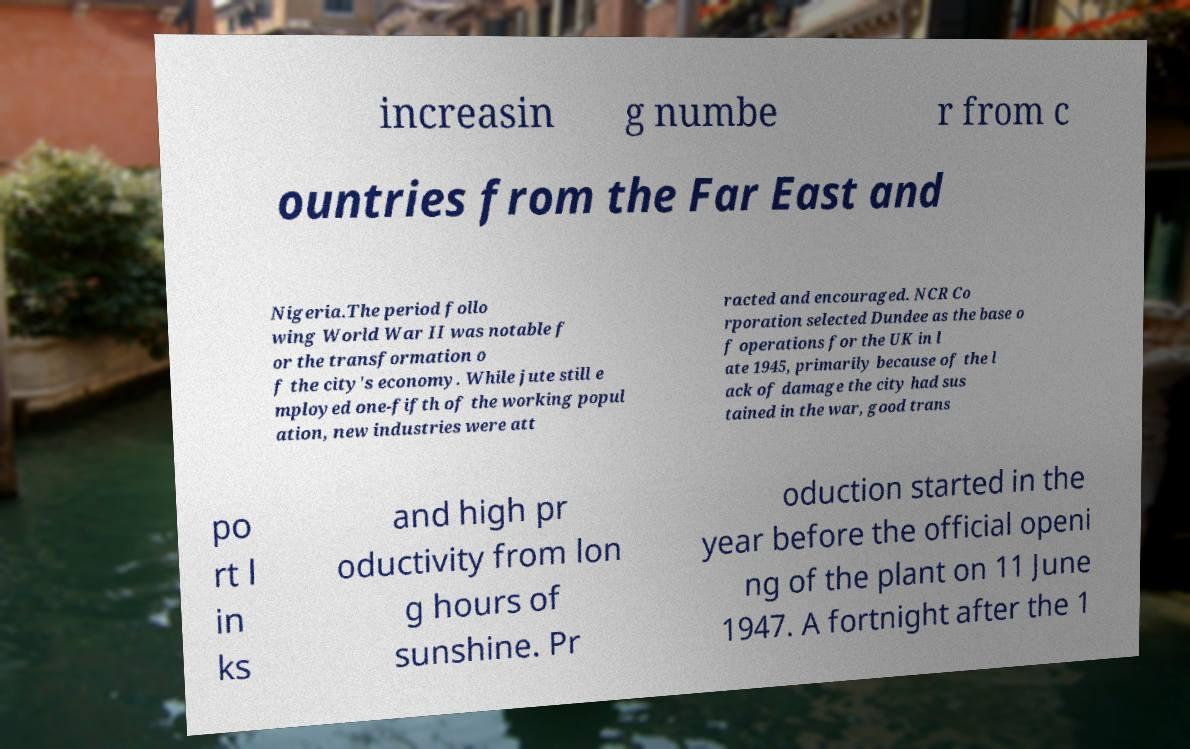Please identify and transcribe the text found in this image. increasin g numbe r from c ountries from the Far East and Nigeria.The period follo wing World War II was notable f or the transformation o f the city's economy. While jute still e mployed one-fifth of the working popul ation, new industries were att racted and encouraged. NCR Co rporation selected Dundee as the base o f operations for the UK in l ate 1945, primarily because of the l ack of damage the city had sus tained in the war, good trans po rt l in ks and high pr oductivity from lon g hours of sunshine. Pr oduction started in the year before the official openi ng of the plant on 11 June 1947. A fortnight after the 1 